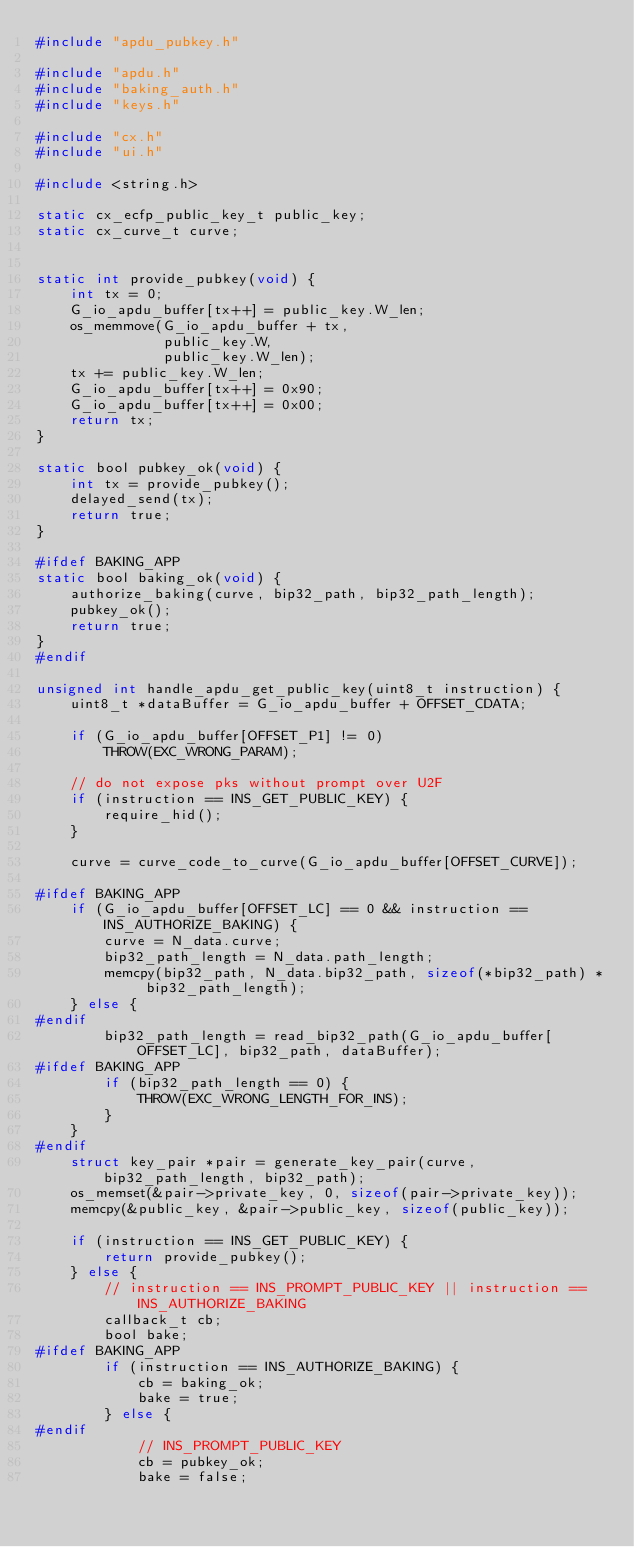Convert code to text. <code><loc_0><loc_0><loc_500><loc_500><_C_>#include "apdu_pubkey.h"

#include "apdu.h"
#include "baking_auth.h"
#include "keys.h"

#include "cx.h"
#include "ui.h"

#include <string.h>

static cx_ecfp_public_key_t public_key;
static cx_curve_t curve;


static int provide_pubkey(void) {
    int tx = 0;
    G_io_apdu_buffer[tx++] = public_key.W_len;
    os_memmove(G_io_apdu_buffer + tx,
               public_key.W,
               public_key.W_len);
    tx += public_key.W_len;
    G_io_apdu_buffer[tx++] = 0x90;
    G_io_apdu_buffer[tx++] = 0x00;
    return tx;
}

static bool pubkey_ok(void) {
    int tx = provide_pubkey();
    delayed_send(tx);
    return true;
}

#ifdef BAKING_APP
static bool baking_ok(void) {
    authorize_baking(curve, bip32_path, bip32_path_length);
    pubkey_ok();
    return true;
}
#endif

unsigned int handle_apdu_get_public_key(uint8_t instruction) {
    uint8_t *dataBuffer = G_io_apdu_buffer + OFFSET_CDATA;

    if (G_io_apdu_buffer[OFFSET_P1] != 0)
        THROW(EXC_WRONG_PARAM);

    // do not expose pks without prompt over U2F
    if (instruction == INS_GET_PUBLIC_KEY) {
        require_hid();
    }

    curve = curve_code_to_curve(G_io_apdu_buffer[OFFSET_CURVE]);

#ifdef BAKING_APP
    if (G_io_apdu_buffer[OFFSET_LC] == 0 && instruction == INS_AUTHORIZE_BAKING) {
        curve = N_data.curve;
        bip32_path_length = N_data.path_length;
        memcpy(bip32_path, N_data.bip32_path, sizeof(*bip32_path) * bip32_path_length);
    } else {
#endif
        bip32_path_length = read_bip32_path(G_io_apdu_buffer[OFFSET_LC], bip32_path, dataBuffer);
#ifdef BAKING_APP
        if (bip32_path_length == 0) {
            THROW(EXC_WRONG_LENGTH_FOR_INS);
        }
    }
#endif
    struct key_pair *pair = generate_key_pair(curve, bip32_path_length, bip32_path);
    os_memset(&pair->private_key, 0, sizeof(pair->private_key));
    memcpy(&public_key, &pair->public_key, sizeof(public_key));

    if (instruction == INS_GET_PUBLIC_KEY) {
        return provide_pubkey();
    } else {
        // instruction == INS_PROMPT_PUBLIC_KEY || instruction == INS_AUTHORIZE_BAKING
        callback_t cb;
        bool bake;
#ifdef BAKING_APP
        if (instruction == INS_AUTHORIZE_BAKING) {
            cb = baking_ok;
            bake = true;
        } else {
#endif
            // INS_PROMPT_PUBLIC_KEY
            cb = pubkey_ok;
            bake = false;</code> 